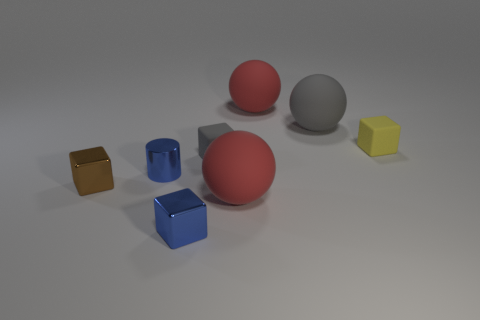What color is the other metallic thing that is the same shape as the small brown metal object? The other metallic object sharing the same cube shape as the small brown one is blue. 